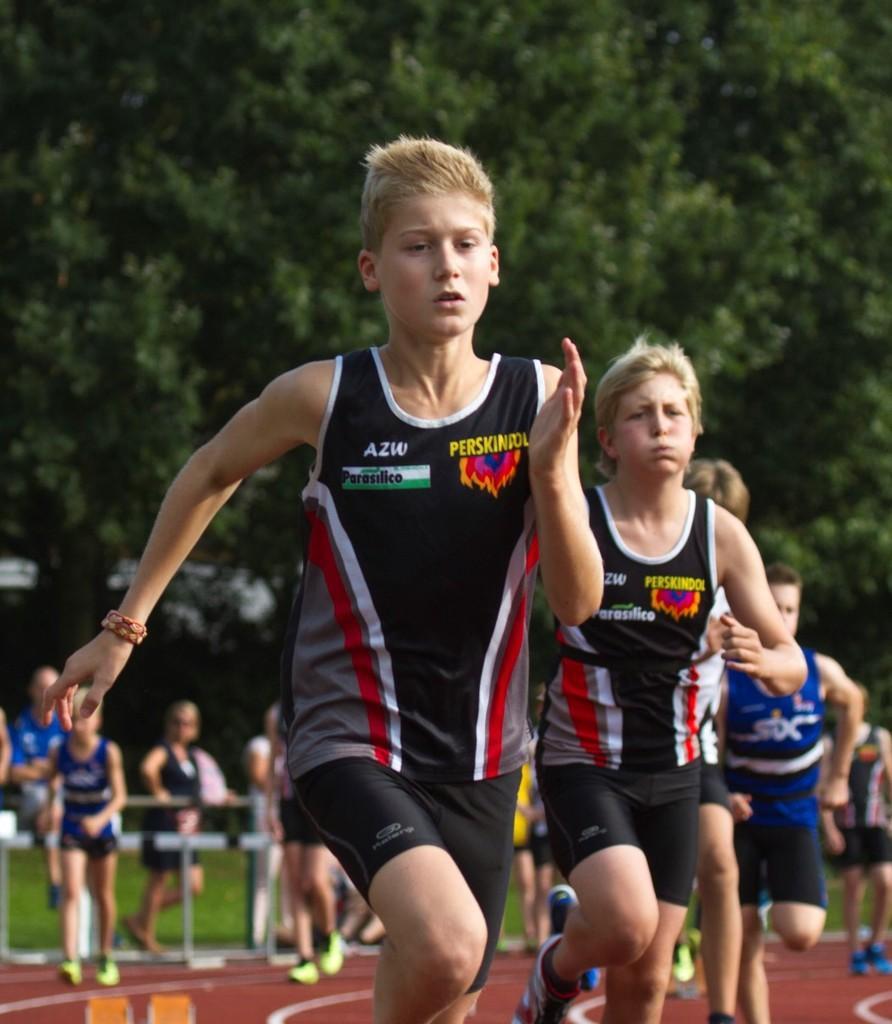Can you describe this image briefly? In this picture there are group of people running. At the back there are group of people standing behind the railing and there are trees and their might be a building. At the bottom there is grass. 